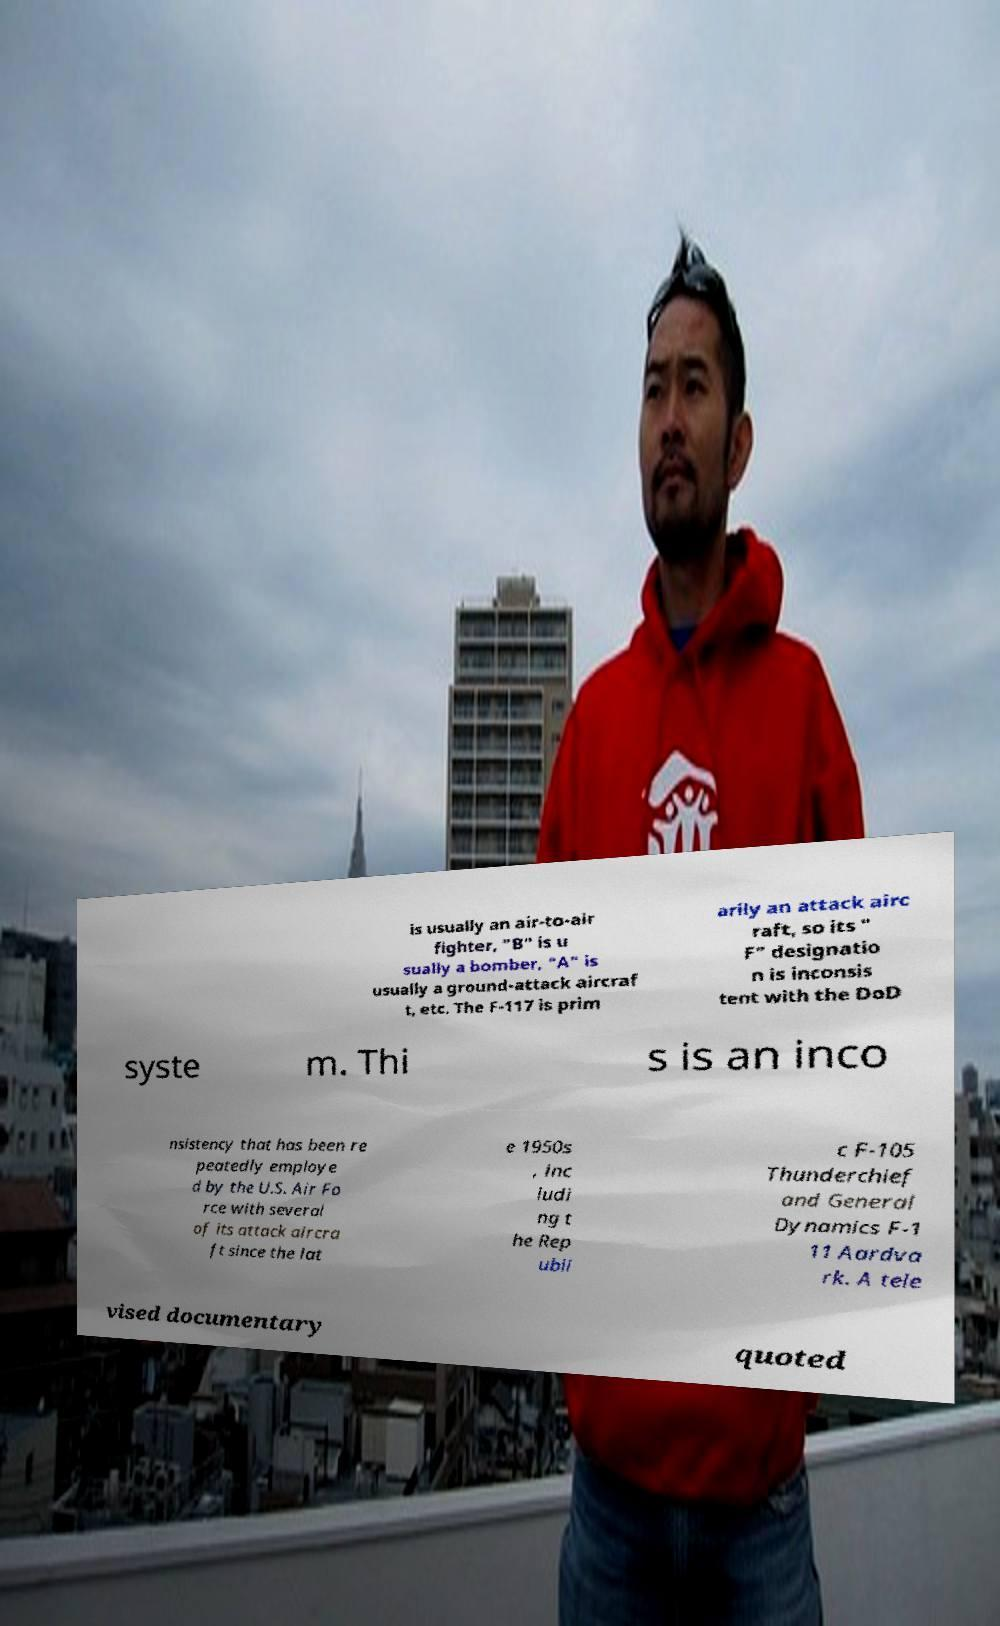For documentation purposes, I need the text within this image transcribed. Could you provide that? is usually an air-to-air fighter, "B" is u sually a bomber, "A" is usually a ground-attack aircraf t, etc. The F-117 is prim arily an attack airc raft, so its " F" designatio n is inconsis tent with the DoD syste m. Thi s is an inco nsistency that has been re peatedly employe d by the U.S. Air Fo rce with several of its attack aircra ft since the lat e 1950s , inc ludi ng t he Rep ubli c F-105 Thunderchief and General Dynamics F-1 11 Aardva rk. A tele vised documentary quoted 